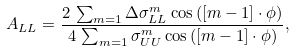Convert formula to latex. <formula><loc_0><loc_0><loc_500><loc_500>A _ { L L } = \frac { 2 \, \sum _ { m = 1 } \Delta \sigma ^ { m } _ { L L } \cos { ( [ m - 1 ] \cdot \phi ) } } { 4 \, \sum _ { m = 1 } \sigma ^ { m } _ { U U } \cos { ( [ m - 1 ] \cdot \phi ) } } ,</formula> 